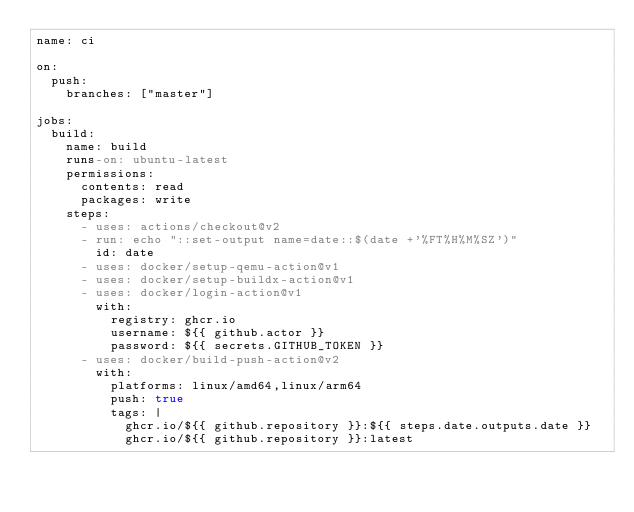<code> <loc_0><loc_0><loc_500><loc_500><_YAML_>name: ci

on:
  push:
    branches: ["master"]

jobs:
  build:
    name: build
    runs-on: ubuntu-latest
    permissions:
      contents: read
      packages: write
    steps:
      - uses: actions/checkout@v2
      - run: echo "::set-output name=date::$(date +'%FT%H%M%SZ')"
        id: date
      - uses: docker/setup-qemu-action@v1
      - uses: docker/setup-buildx-action@v1
      - uses: docker/login-action@v1
        with:
          registry: ghcr.io
          username: ${{ github.actor }}
          password: ${{ secrets.GITHUB_TOKEN }}
      - uses: docker/build-push-action@v2
        with:
          platforms: linux/amd64,linux/arm64
          push: true
          tags: |
            ghcr.io/${{ github.repository }}:${{ steps.date.outputs.date }}
            ghcr.io/${{ github.repository }}:latest
</code> 